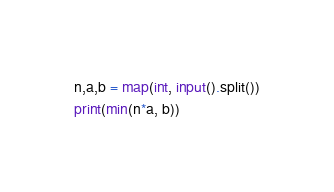<code> <loc_0><loc_0><loc_500><loc_500><_Python_>n,a,b = map(int, input().split())
print(min(n*a, b))</code> 